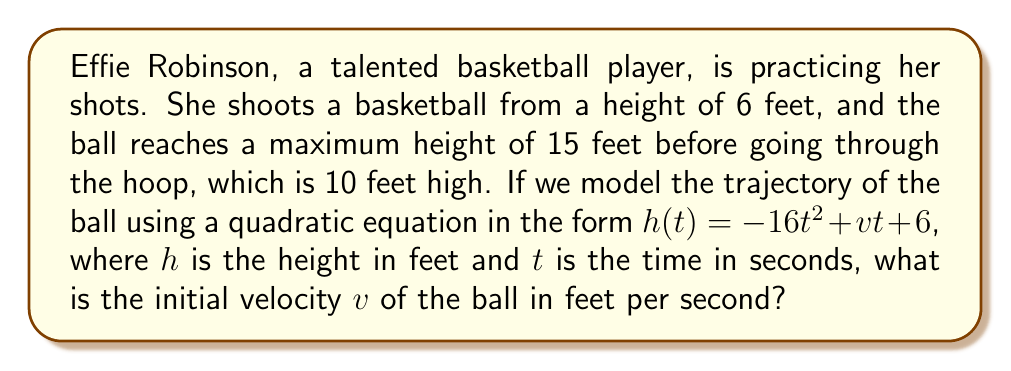Teach me how to tackle this problem. Let's approach this step-by-step:

1) The quadratic equation modeling the trajectory is:
   $$h(t) = -16t^2 + vt + 6$$

2) We know that the ball reaches a maximum height of 15 feet. At this point, the derivative of $h(t)$ with respect to $t$ is zero:
   $$\frac{dh}{dt} = -32t + v = 0$$
   $$32t = v$$
   $$t = \frac{v}{32}$$

3) Substituting this time into our original equation:
   $$15 = -16(\frac{v}{32})^2 + v(\frac{v}{32}) + 6$$

4) Simplify:
   $$15 = -16(\frac{v^2}{1024}) + \frac{v^2}{32} + 6$$
   $$15 = -\frac{v^2}{64} + \frac{v^2}{32} + 6$$
   $$15 = \frac{v^2}{64} + 6$$

5) Solve for $v^2$:
   $$9 = \frac{v^2}{64}$$
   $$v^2 = 576$$

6) Take the square root of both sides:
   $$v = 24$$

Therefore, the initial velocity of the ball is 24 feet per second.
Answer: $v = 24$ feet per second 